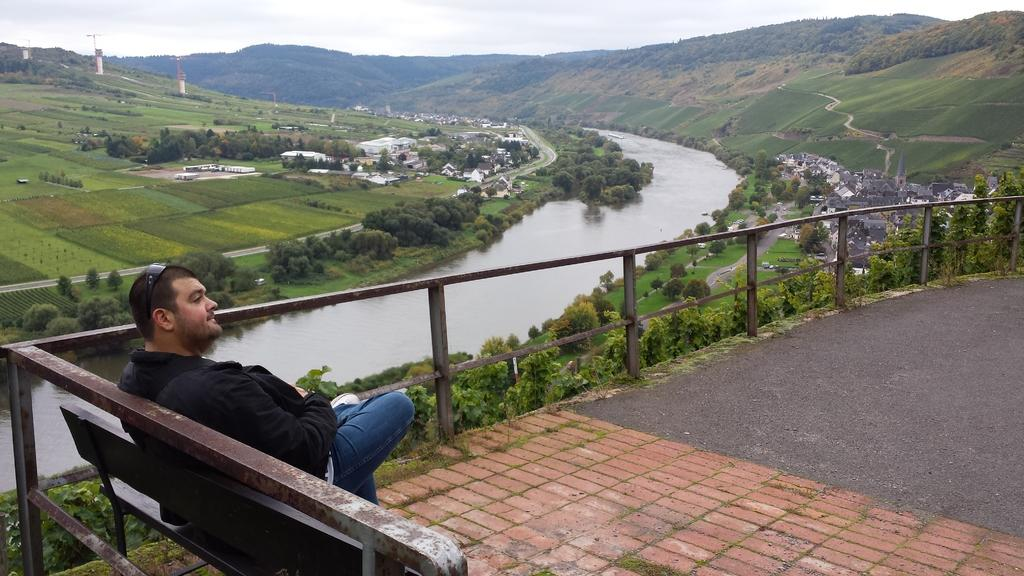What is the man in the image doing? The man is sitting on a bench in the image. What can be seen behind the man? There is a river behind the man. What type of vegetation is present in the image? There are trees visible in the image, and there is a lot of greenery. What natural features can be seen in the distance? There are mountains in the image. Are there any man-made structures visible? Yes, there are houses in the image. What type of vase is sitting on the riverbank in the image? There is no vase present in the image; it features a man sitting on a bench, a river, trees, greenery, mountains, and houses. 